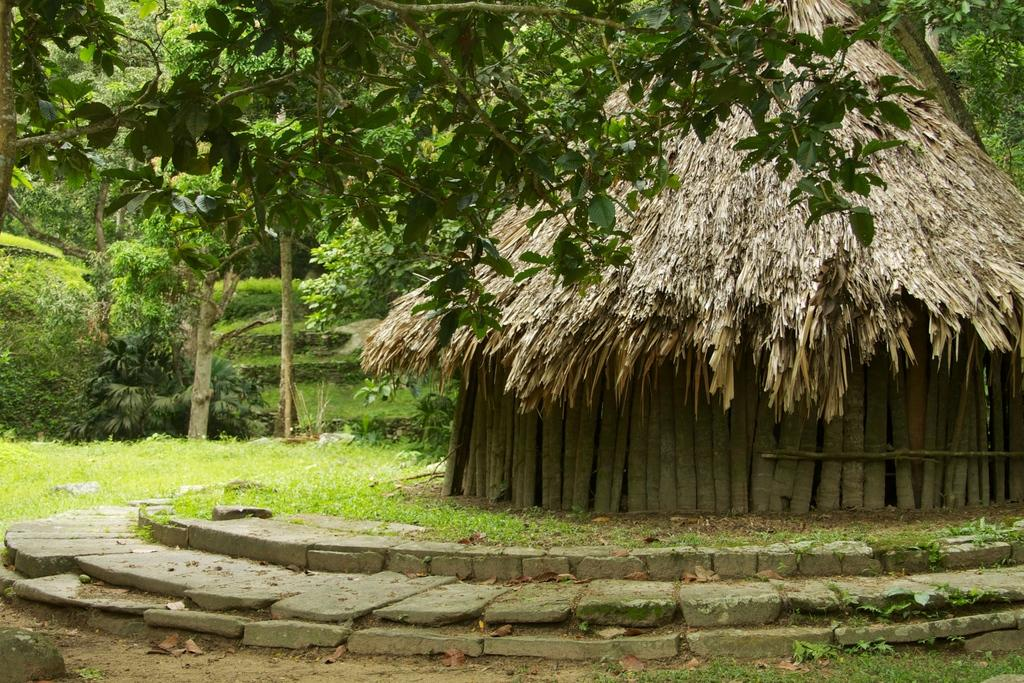What type of structure is present in the image? There is a hut in the image. What natural elements can be seen in the image? There are rocks, grass, plants, and trees in the image. Can you describe the vegetation in the image? The image contains plants and trees. What type of acoustics can be heard in the hut in the image? There is no information about the acoustics in the image, as it only shows a hut and natural elements. 